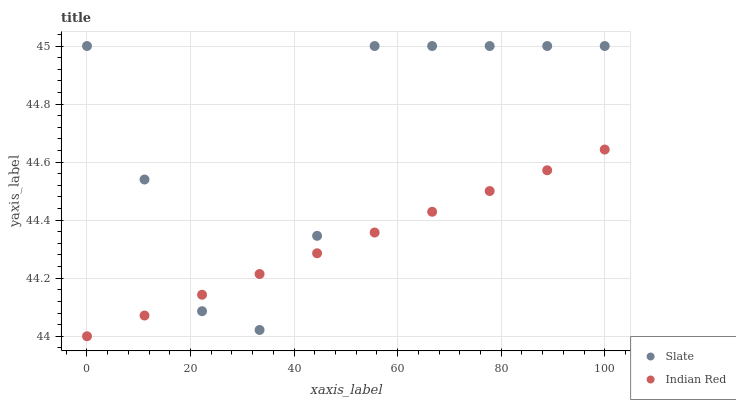Does Indian Red have the minimum area under the curve?
Answer yes or no. Yes. Does Slate have the maximum area under the curve?
Answer yes or no. Yes. Does Indian Red have the maximum area under the curve?
Answer yes or no. No. Is Indian Red the smoothest?
Answer yes or no. Yes. Is Slate the roughest?
Answer yes or no. Yes. Is Indian Red the roughest?
Answer yes or no. No. Does Indian Red have the lowest value?
Answer yes or no. Yes. Does Slate have the highest value?
Answer yes or no. Yes. Does Indian Red have the highest value?
Answer yes or no. No. Does Slate intersect Indian Red?
Answer yes or no. Yes. Is Slate less than Indian Red?
Answer yes or no. No. Is Slate greater than Indian Red?
Answer yes or no. No. 